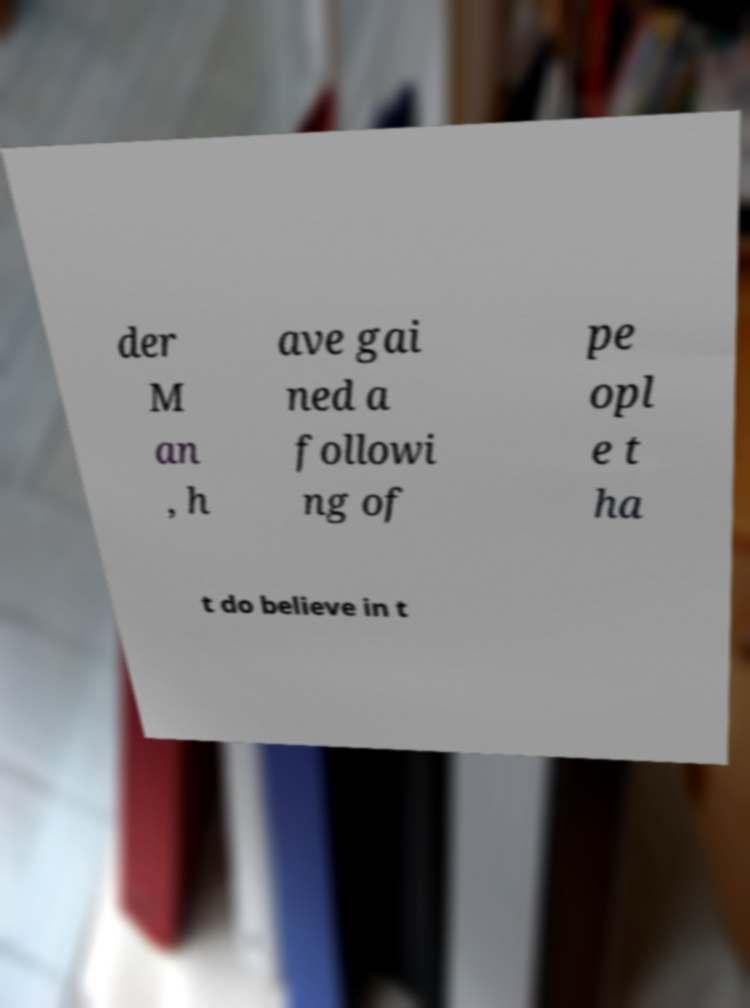I need the written content from this picture converted into text. Can you do that? der M an , h ave gai ned a followi ng of pe opl e t ha t do believe in t 